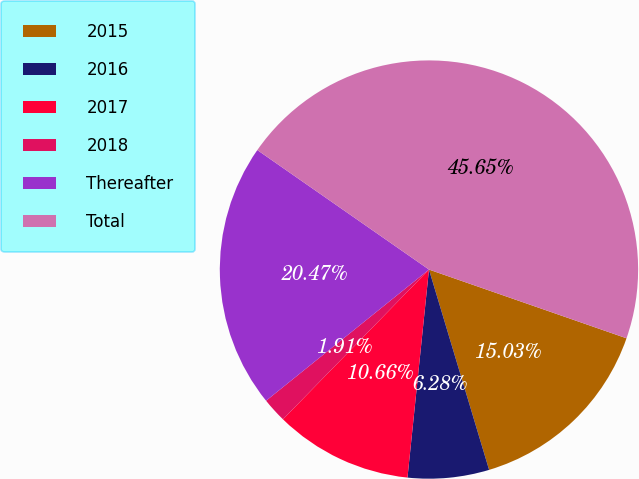Convert chart to OTSL. <chart><loc_0><loc_0><loc_500><loc_500><pie_chart><fcel>2015<fcel>2016<fcel>2017<fcel>2018<fcel>Thereafter<fcel>Total<nl><fcel>15.03%<fcel>6.28%<fcel>10.66%<fcel>1.91%<fcel>20.47%<fcel>45.65%<nl></chart> 